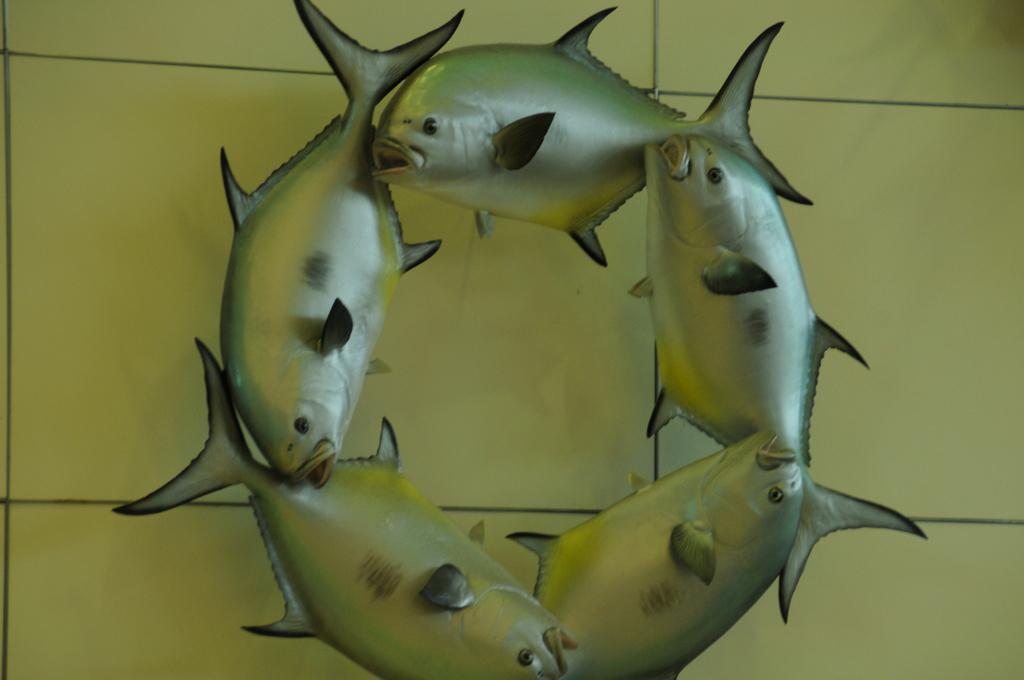Can you describe this image briefly? In this image, we can see fish sculptures and in the background, there is a wall. 